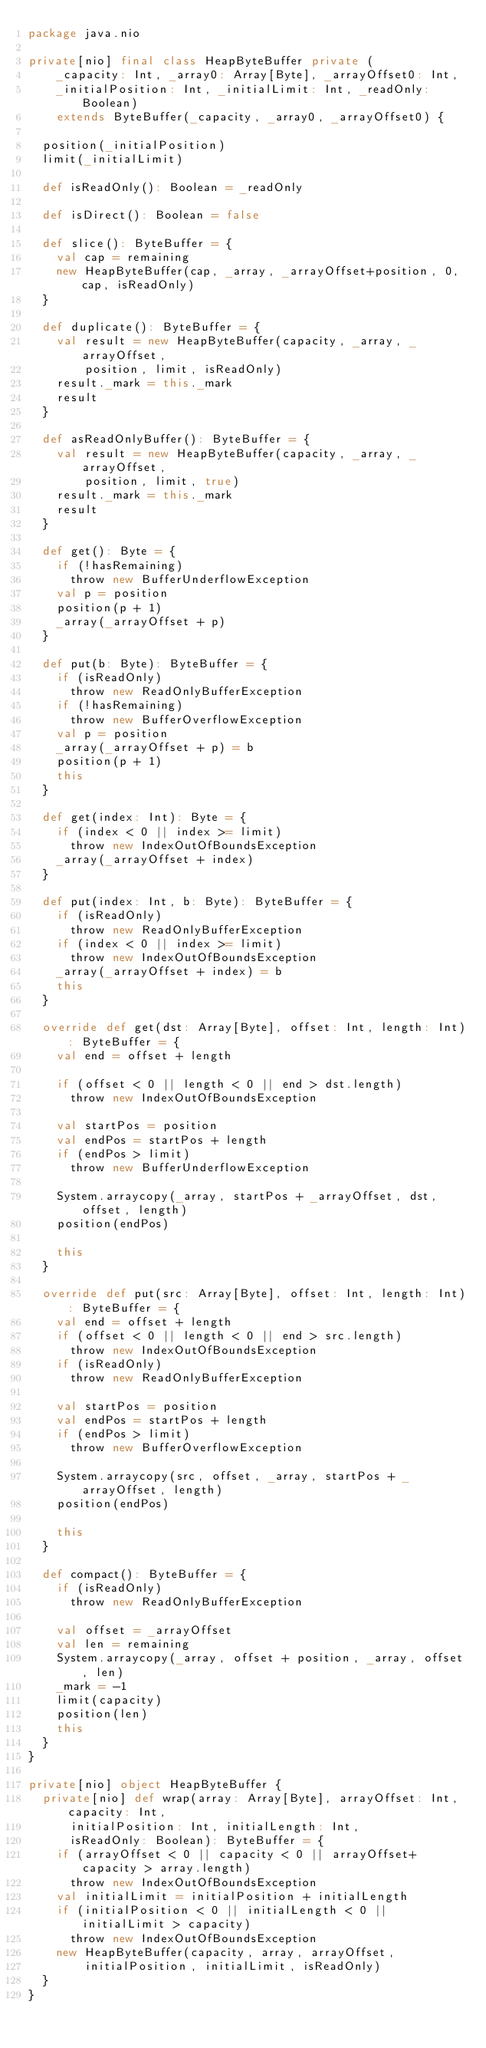Convert code to text. <code><loc_0><loc_0><loc_500><loc_500><_Scala_>package java.nio

private[nio] final class HeapByteBuffer private (
    _capacity: Int, _array0: Array[Byte], _arrayOffset0: Int,
    _initialPosition: Int, _initialLimit: Int, _readOnly: Boolean)
    extends ByteBuffer(_capacity, _array0, _arrayOffset0) {

  position(_initialPosition)
  limit(_initialLimit)

  def isReadOnly(): Boolean = _readOnly

  def isDirect(): Boolean = false

  def slice(): ByteBuffer = {
    val cap = remaining
    new HeapByteBuffer(cap, _array, _arrayOffset+position, 0, cap, isReadOnly)
  }

  def duplicate(): ByteBuffer = {
    val result = new HeapByteBuffer(capacity, _array, _arrayOffset,
        position, limit, isReadOnly)
    result._mark = this._mark
    result
  }

  def asReadOnlyBuffer(): ByteBuffer = {
    val result = new HeapByteBuffer(capacity, _array, _arrayOffset,
        position, limit, true)
    result._mark = this._mark
    result
  }

  def get(): Byte = {
    if (!hasRemaining)
      throw new BufferUnderflowException
    val p = position
    position(p + 1)
    _array(_arrayOffset + p)
  }

  def put(b: Byte): ByteBuffer = {
    if (isReadOnly)
      throw new ReadOnlyBufferException
    if (!hasRemaining)
      throw new BufferOverflowException
    val p = position
    _array(_arrayOffset + p) = b
    position(p + 1)
    this
  }

  def get(index: Int): Byte = {
    if (index < 0 || index >= limit)
      throw new IndexOutOfBoundsException
    _array(_arrayOffset + index)
  }

  def put(index: Int, b: Byte): ByteBuffer = {
    if (isReadOnly)
      throw new ReadOnlyBufferException
    if (index < 0 || index >= limit)
      throw new IndexOutOfBoundsException
    _array(_arrayOffset + index) = b
    this
  }

  override def get(dst: Array[Byte], offset: Int, length: Int): ByteBuffer = {
    val end = offset + length

    if (offset < 0 || length < 0 || end > dst.length)
      throw new IndexOutOfBoundsException

    val startPos = position
    val endPos = startPos + length
    if (endPos > limit)
      throw new BufferUnderflowException

    System.arraycopy(_array, startPos + _arrayOffset, dst, offset, length)
    position(endPos)

    this
  }

  override def put(src: Array[Byte], offset: Int, length: Int): ByteBuffer = {
    val end = offset + length
    if (offset < 0 || length < 0 || end > src.length)
      throw new IndexOutOfBoundsException
    if (isReadOnly)
      throw new ReadOnlyBufferException

    val startPos = position
    val endPos = startPos + length
    if (endPos > limit)
      throw new BufferOverflowException

    System.arraycopy(src, offset, _array, startPos + _arrayOffset, length)
    position(endPos)

    this
  }

  def compact(): ByteBuffer = {
    if (isReadOnly)
      throw new ReadOnlyBufferException

    val offset = _arrayOffset
    val len = remaining
    System.arraycopy(_array, offset + position, _array, offset, len)
    _mark = -1
    limit(capacity)
    position(len)
    this
  }
}

private[nio] object HeapByteBuffer {
  private[nio] def wrap(array: Array[Byte], arrayOffset: Int, capacity: Int,
      initialPosition: Int, initialLength: Int,
      isReadOnly: Boolean): ByteBuffer = {
    if (arrayOffset < 0 || capacity < 0 || arrayOffset+capacity > array.length)
      throw new IndexOutOfBoundsException
    val initialLimit = initialPosition + initialLength
    if (initialPosition < 0 || initialLength < 0 || initialLimit > capacity)
      throw new IndexOutOfBoundsException
    new HeapByteBuffer(capacity, array, arrayOffset,
        initialPosition, initialLimit, isReadOnly)
  }
}
</code> 